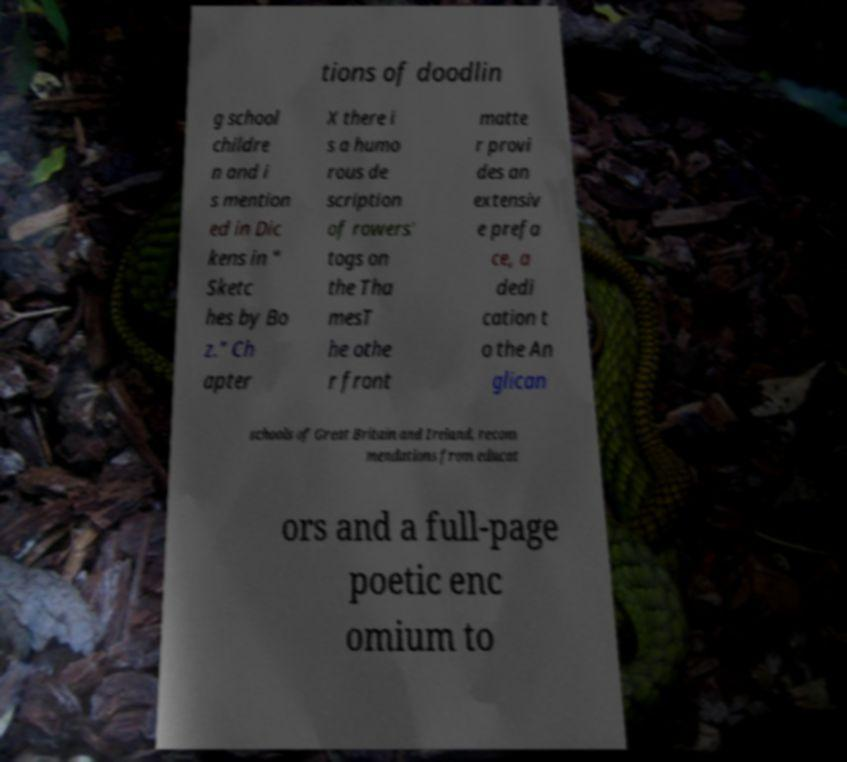Please read and relay the text visible in this image. What does it say? tions of doodlin g school childre n and i s mention ed in Dic kens in " Sketc hes by Bo z." Ch apter X there i s a humo rous de scription of rowers' togs on the Tha mesT he othe r front matte r provi des an extensiv e prefa ce, a dedi cation t o the An glican schools of Great Britain and Ireland, recom mendations from educat ors and a full-page poetic enc omium to 